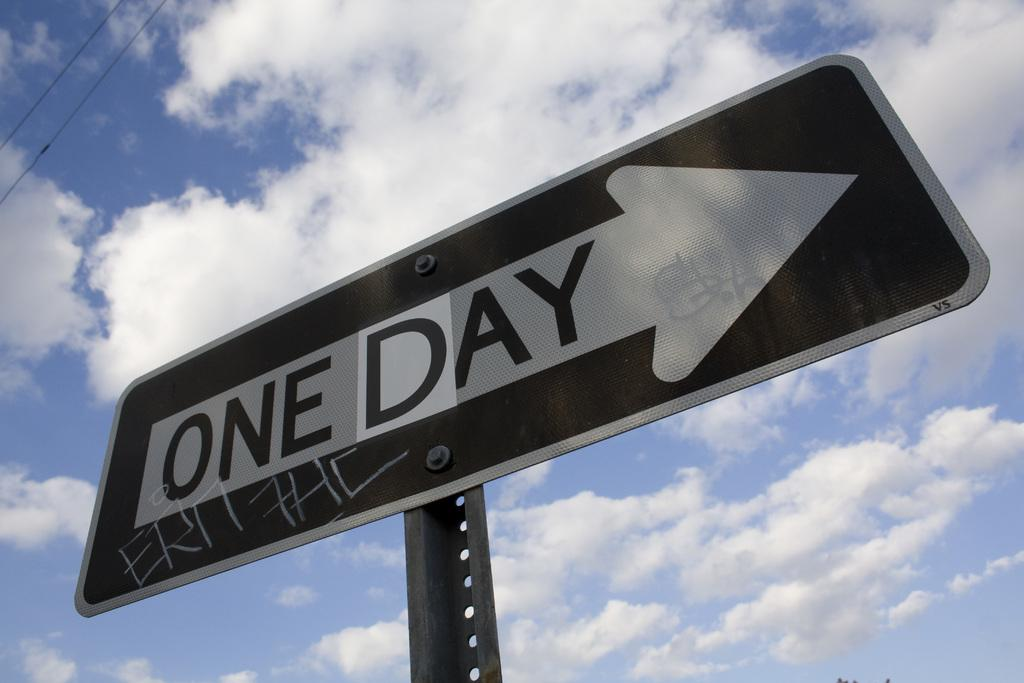<image>
Offer a succinct explanation of the picture presented. A One Way sign that has been vandalized to say one day and has graffiti on it. 